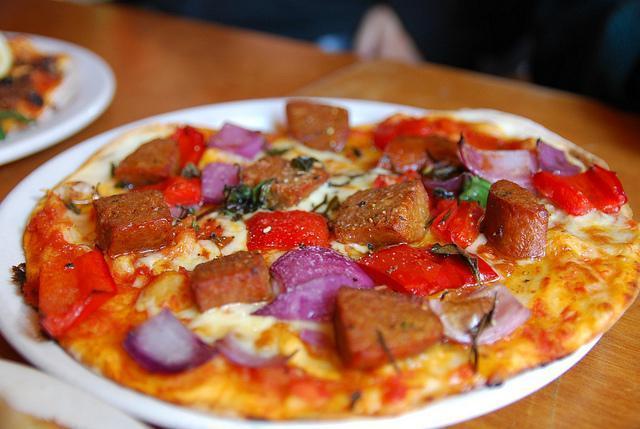How many pizzas are in the photo?
Give a very brief answer. 2. 